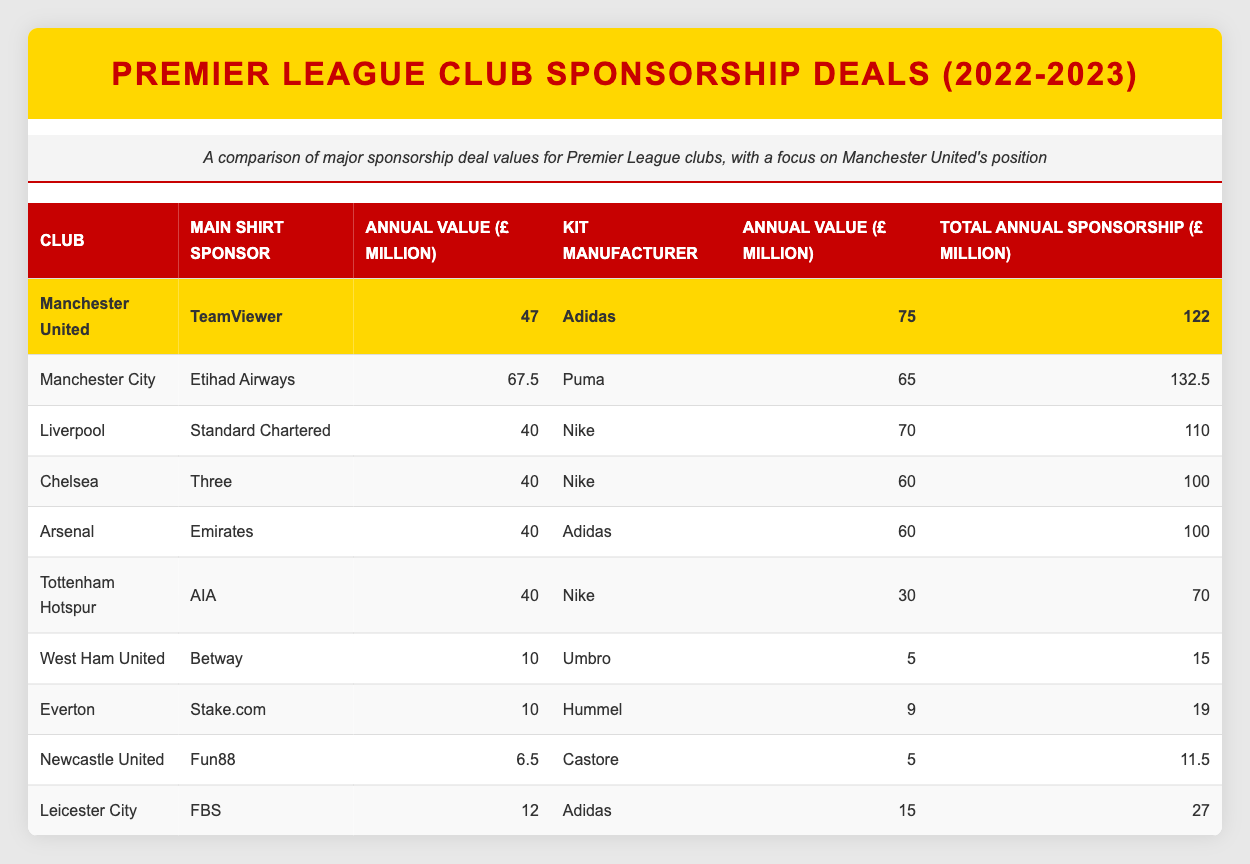What is the total annual sponsorship value for Manchester United? The table shows that Manchester United has a total annual sponsorship value of £122 million. This value is directly listed in the last column of the Manchester United row.
Answer: 122 million Which club has the highest total annual sponsorship value? By comparing the total annual sponsorship values in the last column, Manchester City has the highest value at £132.5 million, while Manchester United follows with £122 million.
Answer: Manchester City What is the difference between the total annual sponsorship values of Manchester United and Liverpool? Manchester United's total annual sponsorship value is £122 million, and Liverpool's is £110 million. To find the difference, subtract Liverpool's value from Manchester United's: 122 - 110 = 12 million.
Answer: 12 million Is the annual value for Manchester United’s main shirt sponsor higher than that of Chelsea's? Manchester United's main shirt sponsor, TeamViewer, has an annual value of £47 million, while Chelsea's main shirt sponsor, Three, has an annual value of £40 million. Since £47 million is greater than £40 million, the statement is true.
Answer: Yes What is the average annual value of the kit manufacturers for all clubs listed? First, sum the annual values of the kit manufacturers: 75 (Adidas) + 65 (Puma) + 70 (Nike) + 60 (Nike) + 60 (Adidas) + 30 (Nike) + 5 (Umbro) + 9 (Hummel) + 5 (Castore) + 15 (Adidas) = 455 million. There are 10 clubs, so the average is 455 / 10 = 45.5 million.
Answer: 45.5 million Which clubs have a total annual sponsorship value below 50 million? By analyzing the total annual sponsorship values, West Ham United has £15 million, Everton has £19 million, and Newcastle United has £11.5 million. All these values are below 50 million.
Answer: West Ham United, Everton, Newcastle United How much is the total annual sponsorship value for all clubs combined? To find the total, add up all the total annual sponsorship values: 122 + 132.5 + 110 + 100 + 100 + 70 + 15 + 19 + 11.5 + 27 =  1007 million.
Answer: 1007 million Is Liverpool's total annual sponsorship value greater than Arsenal’s? Liverpool has a total annual sponsorship value of £110 million, while Arsenal’s is £100 million. Since £110 million is greater than £100 million, the statement is true.
Answer: Yes 